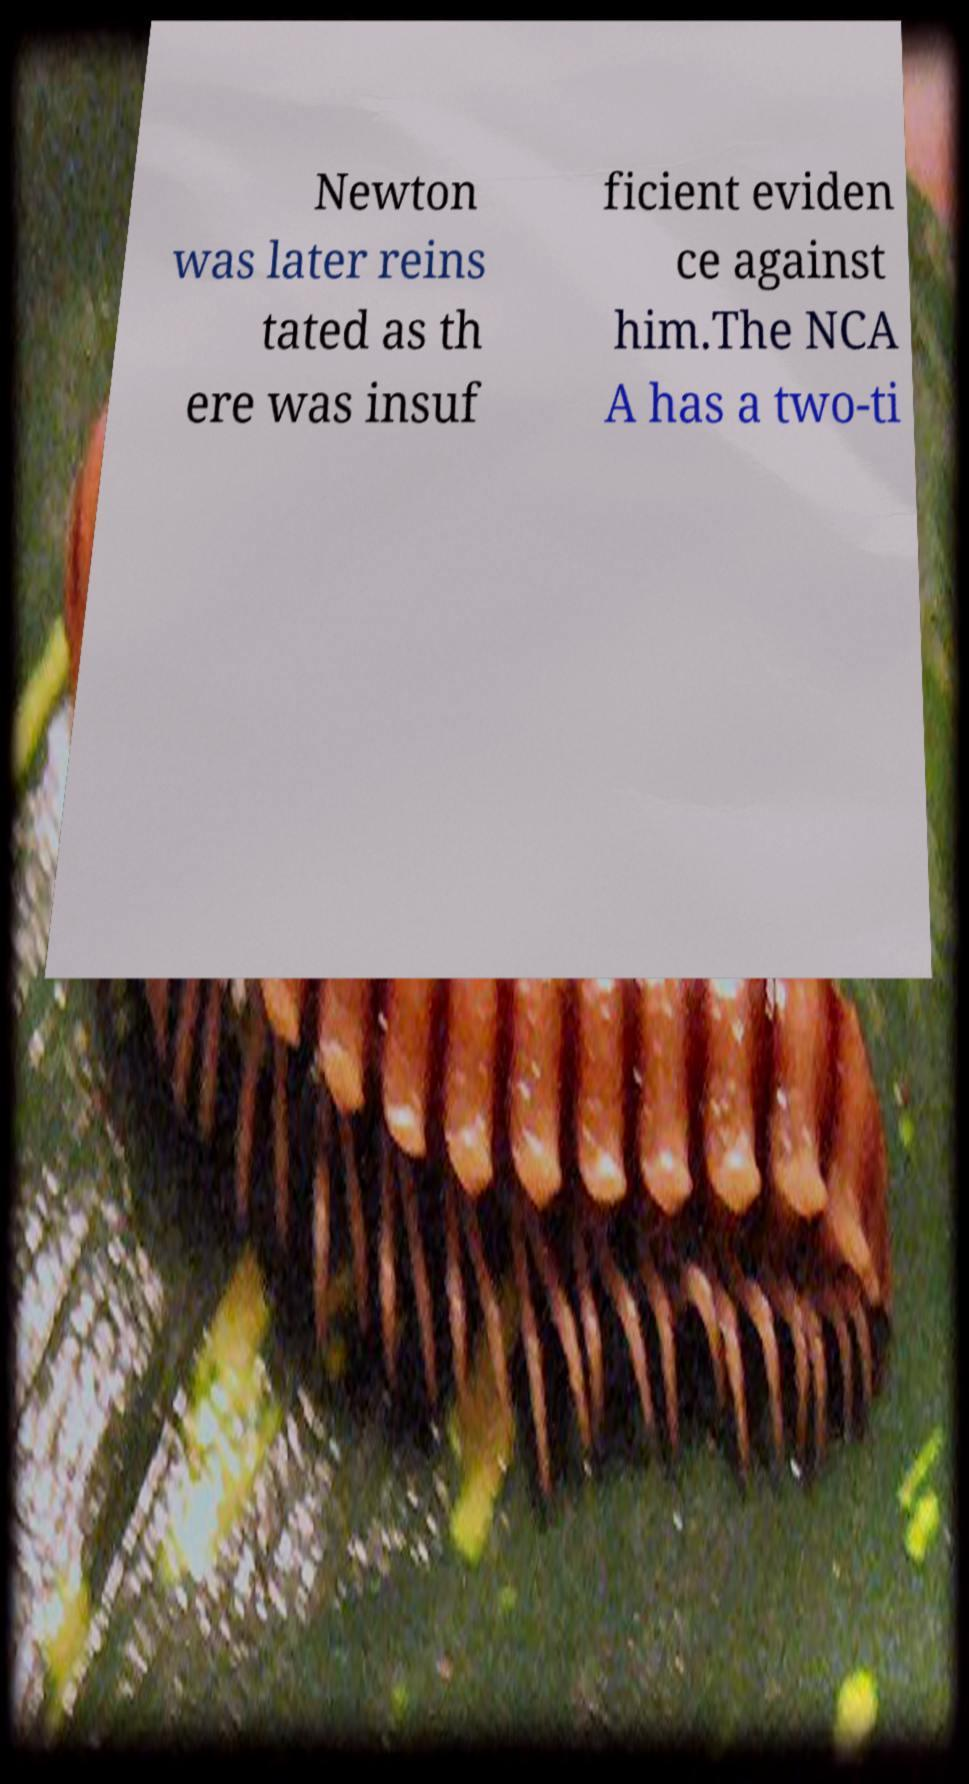Can you read and provide the text displayed in the image?This photo seems to have some interesting text. Can you extract and type it out for me? Newton was later reins tated as th ere was insuf ficient eviden ce against him.The NCA A has a two-ti 